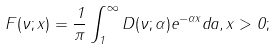<formula> <loc_0><loc_0><loc_500><loc_500>F ( \nu ; x ) = \frac { 1 } { \pi } \int _ { 1 } ^ { \infty } D ( \nu ; \alpha ) e ^ { - \alpha x } d a , x > 0 ;</formula> 